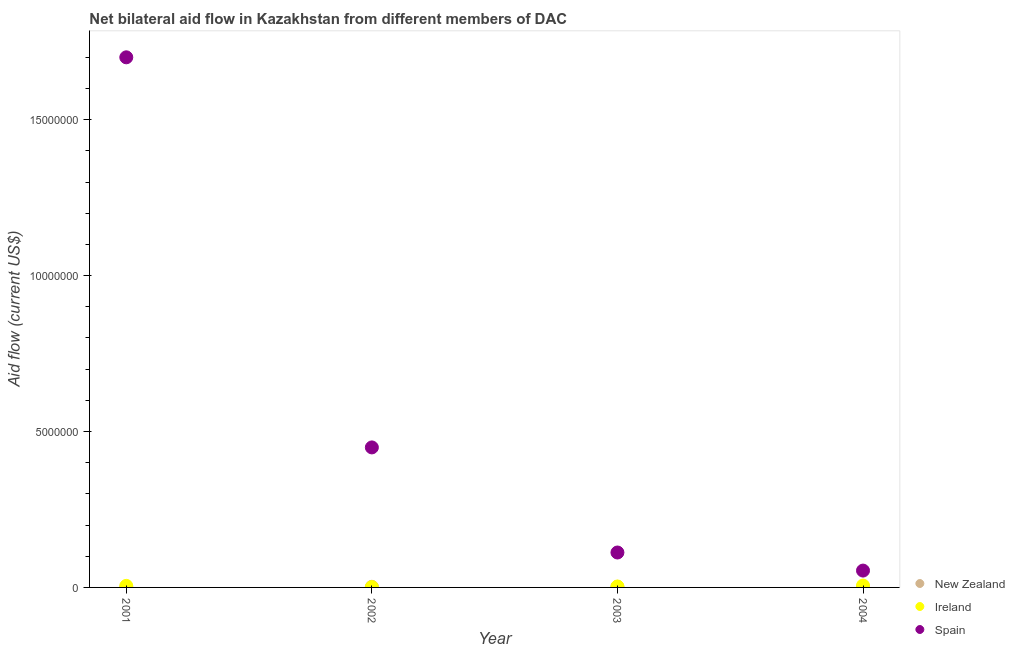What is the amount of aid provided by spain in 2002?
Provide a short and direct response. 4.49e+06. Across all years, what is the maximum amount of aid provided by ireland?
Provide a succinct answer. 6.00e+04. Across all years, what is the minimum amount of aid provided by ireland?
Make the answer very short. 10000. In which year was the amount of aid provided by new zealand maximum?
Keep it short and to the point. 2002. In which year was the amount of aid provided by spain minimum?
Ensure brevity in your answer.  2004. What is the total amount of aid provided by ireland in the graph?
Keep it short and to the point. 1.50e+05. What is the difference between the amount of aid provided by new zealand in 2002 and the amount of aid provided by spain in 2004?
Offer a very short reply. -5.20e+05. What is the average amount of aid provided by spain per year?
Your answer should be compact. 5.79e+06. In the year 2004, what is the difference between the amount of aid provided by spain and amount of aid provided by ireland?
Give a very brief answer. 4.80e+05. In how many years, is the amount of aid provided by spain greater than 1000000 US$?
Give a very brief answer. 3. What is the ratio of the amount of aid provided by spain in 2001 to that in 2003?
Provide a succinct answer. 15.18. Is the amount of aid provided by spain in 2002 less than that in 2003?
Your answer should be compact. No. What is the difference between the highest and the lowest amount of aid provided by new zealand?
Ensure brevity in your answer.  10000. In how many years, is the amount of aid provided by new zealand greater than the average amount of aid provided by new zealand taken over all years?
Provide a short and direct response. 2. Is it the case that in every year, the sum of the amount of aid provided by new zealand and amount of aid provided by ireland is greater than the amount of aid provided by spain?
Offer a very short reply. No. Is the amount of aid provided by spain strictly greater than the amount of aid provided by new zealand over the years?
Keep it short and to the point. Yes. Is the amount of aid provided by new zealand strictly less than the amount of aid provided by spain over the years?
Your answer should be very brief. Yes. How many years are there in the graph?
Your response must be concise. 4. Does the graph contain any zero values?
Keep it short and to the point. No. Where does the legend appear in the graph?
Keep it short and to the point. Bottom right. How many legend labels are there?
Make the answer very short. 3. How are the legend labels stacked?
Offer a terse response. Vertical. What is the title of the graph?
Offer a very short reply. Net bilateral aid flow in Kazakhstan from different members of DAC. What is the label or title of the Y-axis?
Your answer should be compact. Aid flow (current US$). What is the Aid flow (current US$) in Ireland in 2001?
Offer a very short reply. 5.00e+04. What is the Aid flow (current US$) of Spain in 2001?
Provide a succinct answer. 1.70e+07. What is the Aid flow (current US$) in Ireland in 2002?
Provide a short and direct response. 10000. What is the Aid flow (current US$) in Spain in 2002?
Your answer should be compact. 4.49e+06. What is the Aid flow (current US$) in Ireland in 2003?
Offer a terse response. 3.00e+04. What is the Aid flow (current US$) of Spain in 2003?
Your response must be concise. 1.12e+06. What is the Aid flow (current US$) of Ireland in 2004?
Offer a very short reply. 6.00e+04. What is the Aid flow (current US$) of Spain in 2004?
Offer a very short reply. 5.40e+05. Across all years, what is the maximum Aid flow (current US$) in Spain?
Your response must be concise. 1.70e+07. Across all years, what is the minimum Aid flow (current US$) of Ireland?
Offer a very short reply. 10000. Across all years, what is the minimum Aid flow (current US$) in Spain?
Give a very brief answer. 5.40e+05. What is the total Aid flow (current US$) of Spain in the graph?
Provide a succinct answer. 2.32e+07. What is the difference between the Aid flow (current US$) of New Zealand in 2001 and that in 2002?
Keep it short and to the point. -10000. What is the difference between the Aid flow (current US$) of Spain in 2001 and that in 2002?
Provide a succinct answer. 1.25e+07. What is the difference between the Aid flow (current US$) in New Zealand in 2001 and that in 2003?
Ensure brevity in your answer.  -10000. What is the difference between the Aid flow (current US$) in Spain in 2001 and that in 2003?
Keep it short and to the point. 1.59e+07. What is the difference between the Aid flow (current US$) of New Zealand in 2001 and that in 2004?
Your response must be concise. 0. What is the difference between the Aid flow (current US$) in Spain in 2001 and that in 2004?
Ensure brevity in your answer.  1.65e+07. What is the difference between the Aid flow (current US$) of Spain in 2002 and that in 2003?
Offer a very short reply. 3.37e+06. What is the difference between the Aid flow (current US$) in Spain in 2002 and that in 2004?
Your response must be concise. 3.95e+06. What is the difference between the Aid flow (current US$) of Spain in 2003 and that in 2004?
Provide a succinct answer. 5.80e+05. What is the difference between the Aid flow (current US$) in New Zealand in 2001 and the Aid flow (current US$) in Spain in 2002?
Provide a succinct answer. -4.48e+06. What is the difference between the Aid flow (current US$) in Ireland in 2001 and the Aid flow (current US$) in Spain in 2002?
Provide a succinct answer. -4.44e+06. What is the difference between the Aid flow (current US$) in New Zealand in 2001 and the Aid flow (current US$) in Ireland in 2003?
Ensure brevity in your answer.  -2.00e+04. What is the difference between the Aid flow (current US$) in New Zealand in 2001 and the Aid flow (current US$) in Spain in 2003?
Make the answer very short. -1.11e+06. What is the difference between the Aid flow (current US$) of Ireland in 2001 and the Aid flow (current US$) of Spain in 2003?
Offer a very short reply. -1.07e+06. What is the difference between the Aid flow (current US$) in New Zealand in 2001 and the Aid flow (current US$) in Ireland in 2004?
Offer a terse response. -5.00e+04. What is the difference between the Aid flow (current US$) of New Zealand in 2001 and the Aid flow (current US$) of Spain in 2004?
Keep it short and to the point. -5.30e+05. What is the difference between the Aid flow (current US$) of Ireland in 2001 and the Aid flow (current US$) of Spain in 2004?
Make the answer very short. -4.90e+05. What is the difference between the Aid flow (current US$) of New Zealand in 2002 and the Aid flow (current US$) of Spain in 2003?
Provide a short and direct response. -1.10e+06. What is the difference between the Aid flow (current US$) in Ireland in 2002 and the Aid flow (current US$) in Spain in 2003?
Offer a terse response. -1.11e+06. What is the difference between the Aid flow (current US$) in New Zealand in 2002 and the Aid flow (current US$) in Ireland in 2004?
Make the answer very short. -4.00e+04. What is the difference between the Aid flow (current US$) in New Zealand in 2002 and the Aid flow (current US$) in Spain in 2004?
Give a very brief answer. -5.20e+05. What is the difference between the Aid flow (current US$) in Ireland in 2002 and the Aid flow (current US$) in Spain in 2004?
Provide a succinct answer. -5.30e+05. What is the difference between the Aid flow (current US$) of New Zealand in 2003 and the Aid flow (current US$) of Ireland in 2004?
Provide a short and direct response. -4.00e+04. What is the difference between the Aid flow (current US$) in New Zealand in 2003 and the Aid flow (current US$) in Spain in 2004?
Make the answer very short. -5.20e+05. What is the difference between the Aid flow (current US$) in Ireland in 2003 and the Aid flow (current US$) in Spain in 2004?
Your answer should be very brief. -5.10e+05. What is the average Aid flow (current US$) in New Zealand per year?
Offer a very short reply. 1.50e+04. What is the average Aid flow (current US$) in Ireland per year?
Make the answer very short. 3.75e+04. What is the average Aid flow (current US$) of Spain per year?
Your answer should be compact. 5.79e+06. In the year 2001, what is the difference between the Aid flow (current US$) of New Zealand and Aid flow (current US$) of Ireland?
Your response must be concise. -4.00e+04. In the year 2001, what is the difference between the Aid flow (current US$) of New Zealand and Aid flow (current US$) of Spain?
Your answer should be very brief. -1.70e+07. In the year 2001, what is the difference between the Aid flow (current US$) of Ireland and Aid flow (current US$) of Spain?
Provide a succinct answer. -1.70e+07. In the year 2002, what is the difference between the Aid flow (current US$) in New Zealand and Aid flow (current US$) in Ireland?
Give a very brief answer. 10000. In the year 2002, what is the difference between the Aid flow (current US$) in New Zealand and Aid flow (current US$) in Spain?
Your response must be concise. -4.47e+06. In the year 2002, what is the difference between the Aid flow (current US$) of Ireland and Aid flow (current US$) of Spain?
Offer a terse response. -4.48e+06. In the year 2003, what is the difference between the Aid flow (current US$) of New Zealand and Aid flow (current US$) of Spain?
Your response must be concise. -1.10e+06. In the year 2003, what is the difference between the Aid flow (current US$) of Ireland and Aid flow (current US$) of Spain?
Ensure brevity in your answer.  -1.09e+06. In the year 2004, what is the difference between the Aid flow (current US$) in New Zealand and Aid flow (current US$) in Ireland?
Make the answer very short. -5.00e+04. In the year 2004, what is the difference between the Aid flow (current US$) of New Zealand and Aid flow (current US$) of Spain?
Ensure brevity in your answer.  -5.30e+05. In the year 2004, what is the difference between the Aid flow (current US$) of Ireland and Aid flow (current US$) of Spain?
Your answer should be compact. -4.80e+05. What is the ratio of the Aid flow (current US$) of Ireland in 2001 to that in 2002?
Provide a succinct answer. 5. What is the ratio of the Aid flow (current US$) of Spain in 2001 to that in 2002?
Provide a short and direct response. 3.79. What is the ratio of the Aid flow (current US$) in New Zealand in 2001 to that in 2003?
Give a very brief answer. 0.5. What is the ratio of the Aid flow (current US$) of Ireland in 2001 to that in 2003?
Make the answer very short. 1.67. What is the ratio of the Aid flow (current US$) of Spain in 2001 to that in 2003?
Provide a short and direct response. 15.18. What is the ratio of the Aid flow (current US$) of New Zealand in 2001 to that in 2004?
Your answer should be compact. 1. What is the ratio of the Aid flow (current US$) of Ireland in 2001 to that in 2004?
Offer a very short reply. 0.83. What is the ratio of the Aid flow (current US$) of Spain in 2001 to that in 2004?
Your answer should be compact. 31.48. What is the ratio of the Aid flow (current US$) in Ireland in 2002 to that in 2003?
Your answer should be compact. 0.33. What is the ratio of the Aid flow (current US$) in Spain in 2002 to that in 2003?
Keep it short and to the point. 4.01. What is the ratio of the Aid flow (current US$) of Ireland in 2002 to that in 2004?
Offer a very short reply. 0.17. What is the ratio of the Aid flow (current US$) of Spain in 2002 to that in 2004?
Your response must be concise. 8.31. What is the ratio of the Aid flow (current US$) of New Zealand in 2003 to that in 2004?
Give a very brief answer. 2. What is the ratio of the Aid flow (current US$) in Ireland in 2003 to that in 2004?
Your answer should be compact. 0.5. What is the ratio of the Aid flow (current US$) in Spain in 2003 to that in 2004?
Provide a short and direct response. 2.07. What is the difference between the highest and the second highest Aid flow (current US$) of New Zealand?
Provide a short and direct response. 0. What is the difference between the highest and the second highest Aid flow (current US$) in Ireland?
Your answer should be very brief. 10000. What is the difference between the highest and the second highest Aid flow (current US$) of Spain?
Ensure brevity in your answer.  1.25e+07. What is the difference between the highest and the lowest Aid flow (current US$) of New Zealand?
Offer a very short reply. 10000. What is the difference between the highest and the lowest Aid flow (current US$) in Ireland?
Ensure brevity in your answer.  5.00e+04. What is the difference between the highest and the lowest Aid flow (current US$) of Spain?
Ensure brevity in your answer.  1.65e+07. 